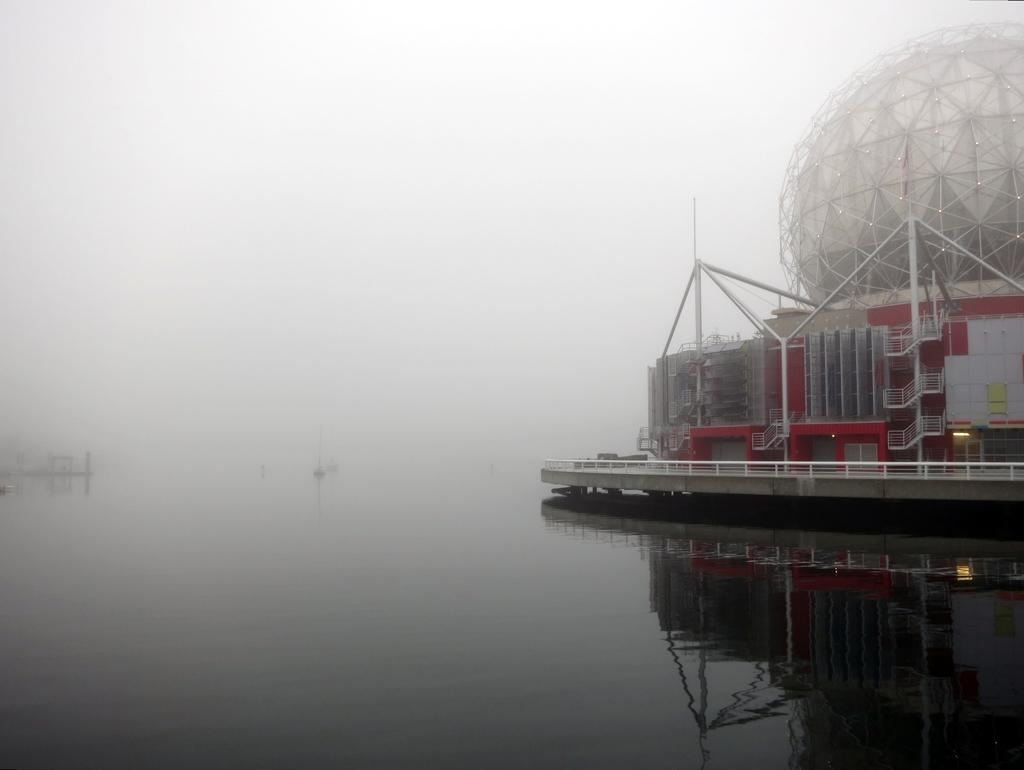What is the main subject of the image? The main subject of the image is a ship. Can you describe the ship's position in relation to the water? The ship is above the water in the image. What can be seen in the background of the image? The background of the image is blurry, and the sky is visible. What type of harmony is being played by the musicians in the image? There are no musicians or any indication of music in the image; it features a ship above the water with a blurry background and visible sky. 